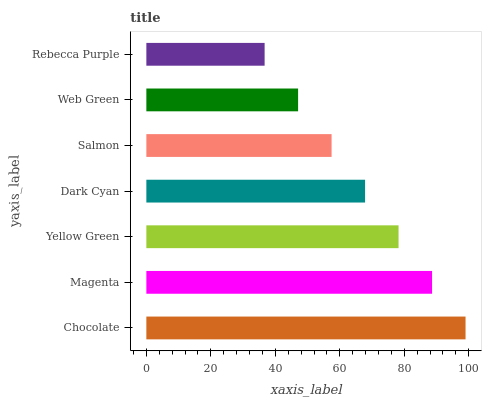Is Rebecca Purple the minimum?
Answer yes or no. Yes. Is Chocolate the maximum?
Answer yes or no. Yes. Is Magenta the minimum?
Answer yes or no. No. Is Magenta the maximum?
Answer yes or no. No. Is Chocolate greater than Magenta?
Answer yes or no. Yes. Is Magenta less than Chocolate?
Answer yes or no. Yes. Is Magenta greater than Chocolate?
Answer yes or no. No. Is Chocolate less than Magenta?
Answer yes or no. No. Is Dark Cyan the high median?
Answer yes or no. Yes. Is Dark Cyan the low median?
Answer yes or no. Yes. Is Rebecca Purple the high median?
Answer yes or no. No. Is Rebecca Purple the low median?
Answer yes or no. No. 